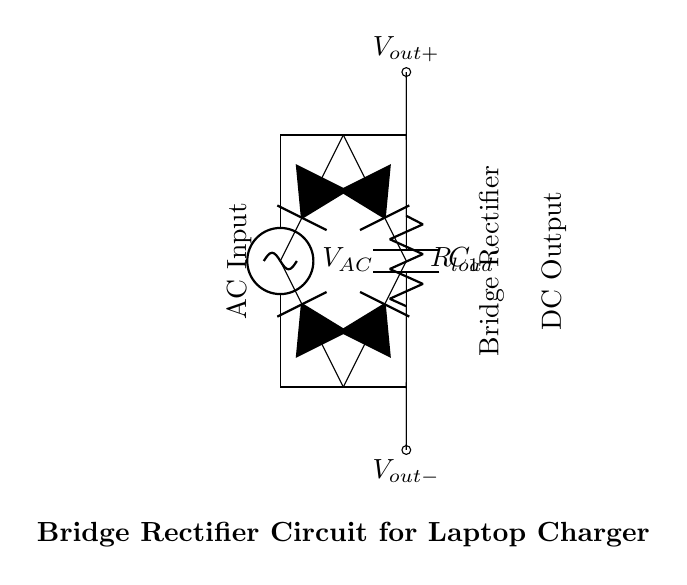What is the type of rectifier shown in the diagram? The circuit depicts a bridge rectifier, which is a type of rectifier that uses four diodes arranged cleverly to convert both halves of the AC input into DC.
Answer: bridge rectifier What component is used to smooth the output voltage? The component used for smoothing the output voltage in the circuit is the capacitor labeled as C1. This component helps to reduce the voltage ripple and provide a more constant DC voltage.
Answer: C1 How many diodes are present in the circuit? There are four diodes used in this bridge rectifier configuration. Each diode conducts during different halves of the AC cycle to ensure that the output remains unidirectional.
Answer: four What is the role of the load resistor in this circuit? The load resistor, labeled as R_load, is responsible for providing a load for the rectified output. It consumes power from the output voltage and is essential for testing or utilizing the output from the rectifier.
Answer: R_load What is the output voltage of the bridge rectifier as marked? The output voltage is indicated at V_out+, which is the positive terminal of the output. The exact voltage isn't specified here, but it represents the voltage after rectification.
Answer: V_out+ Which two terminals are connected to the AC source? The connection to the AC source is made at the top and bottom terminals of the rectifier, showing that they are connected to the alternating voltage supply.
Answer: top and bottom terminals Why is a bridge rectifier preferred over a half-wave rectifier in laptop chargers? A bridge rectifier is preferred because it allows for full-wave rectification, which provides a smoother DC output with better efficiency and less ripple compared to a half-wave rectifier, making it suitable for powering sensitive electronic devices.
Answer: full-wave rectification 